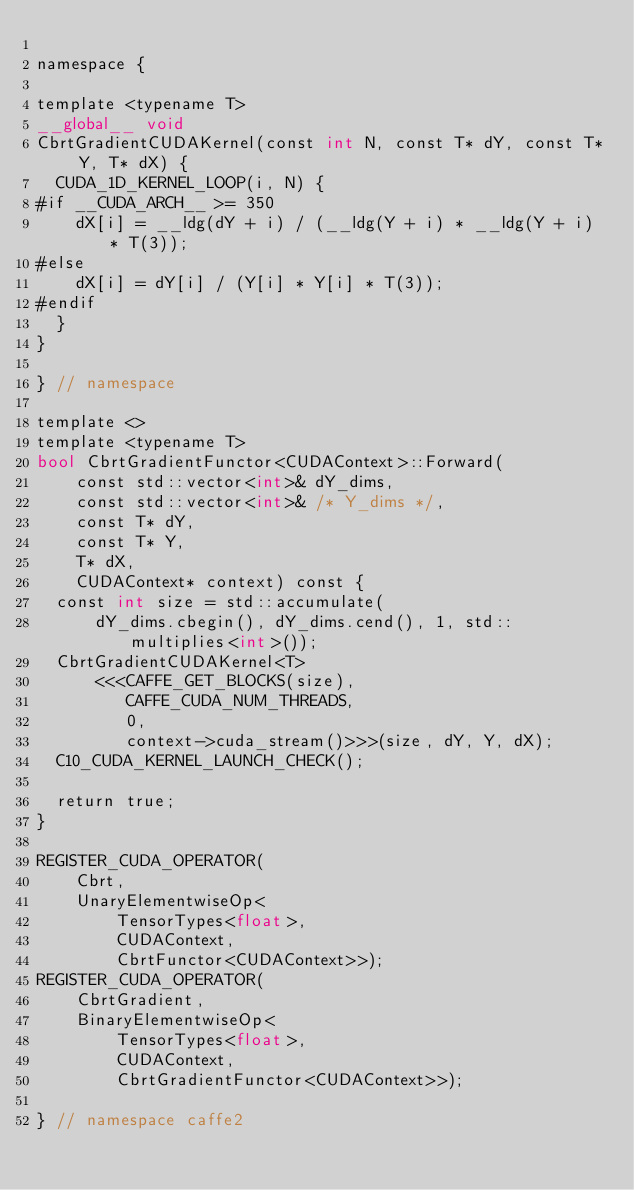<code> <loc_0><loc_0><loc_500><loc_500><_Cuda_>
namespace {

template <typename T>
__global__ void
CbrtGradientCUDAKernel(const int N, const T* dY, const T* Y, T* dX) {
  CUDA_1D_KERNEL_LOOP(i, N) {
#if __CUDA_ARCH__ >= 350
    dX[i] = __ldg(dY + i) / (__ldg(Y + i) * __ldg(Y + i) * T(3));
#else
    dX[i] = dY[i] / (Y[i] * Y[i] * T(3));
#endif
  }
}

} // namespace

template <>
template <typename T>
bool CbrtGradientFunctor<CUDAContext>::Forward(
    const std::vector<int>& dY_dims,
    const std::vector<int>& /* Y_dims */,
    const T* dY,
    const T* Y,
    T* dX,
    CUDAContext* context) const {
  const int size = std::accumulate(
      dY_dims.cbegin(), dY_dims.cend(), 1, std::multiplies<int>());
  CbrtGradientCUDAKernel<T>
      <<<CAFFE_GET_BLOCKS(size),
         CAFFE_CUDA_NUM_THREADS,
         0,
         context->cuda_stream()>>>(size, dY, Y, dX);
  C10_CUDA_KERNEL_LAUNCH_CHECK();

  return true;
}

REGISTER_CUDA_OPERATOR(
    Cbrt,
    UnaryElementwiseOp<
        TensorTypes<float>,
        CUDAContext,
        CbrtFunctor<CUDAContext>>);
REGISTER_CUDA_OPERATOR(
    CbrtGradient,
    BinaryElementwiseOp<
        TensorTypes<float>,
        CUDAContext,
        CbrtGradientFunctor<CUDAContext>>);

} // namespace caffe2
</code> 